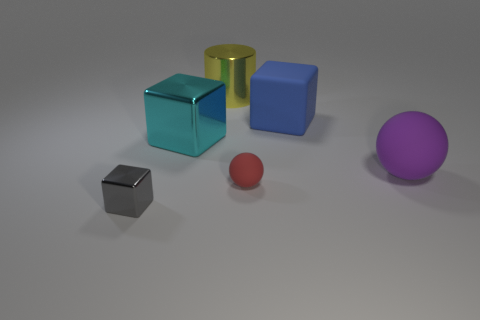There is another rubber object that is the same shape as the big purple matte thing; what is its size?
Your response must be concise. Small. How many small objects are behind the cube left of the large cube that is on the left side of the tiny rubber sphere?
Make the answer very short. 1. What number of cubes are big things or metallic things?
Ensure brevity in your answer.  3. What is the color of the large cube that is on the right side of the small object behind the object on the left side of the cyan metallic object?
Offer a terse response. Blue. What number of other things are there of the same size as the purple matte ball?
Ensure brevity in your answer.  3. Is there anything else that has the same shape as the cyan metallic object?
Your response must be concise. Yes. What color is the other thing that is the same shape as the tiny red thing?
Your response must be concise. Purple. What color is the large block that is made of the same material as the yellow cylinder?
Offer a terse response. Cyan. Are there an equal number of small red things that are behind the cyan thing and big cyan metallic blocks?
Offer a terse response. No. Does the cube that is on the right side of the yellow cylinder have the same size as the yellow metallic cylinder?
Keep it short and to the point. Yes. 